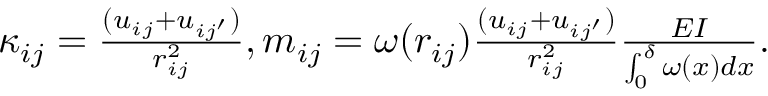<formula> <loc_0><loc_0><loc_500><loc_500>\begin{array} { r } { \kappa _ { i j } = \frac { ( u _ { i j } + u _ { i j ^ { \prime } } ) } { r _ { i j } ^ { 2 } } , m _ { i j } = \omega ( r _ { i j } ) \frac { ( u _ { i j } + u _ { i j ^ { \prime } } ) } { r _ { i j } ^ { 2 } } \frac { E I } { \int _ { 0 } ^ { \delta } \omega ( x ) d x } . } \end{array}</formula> 